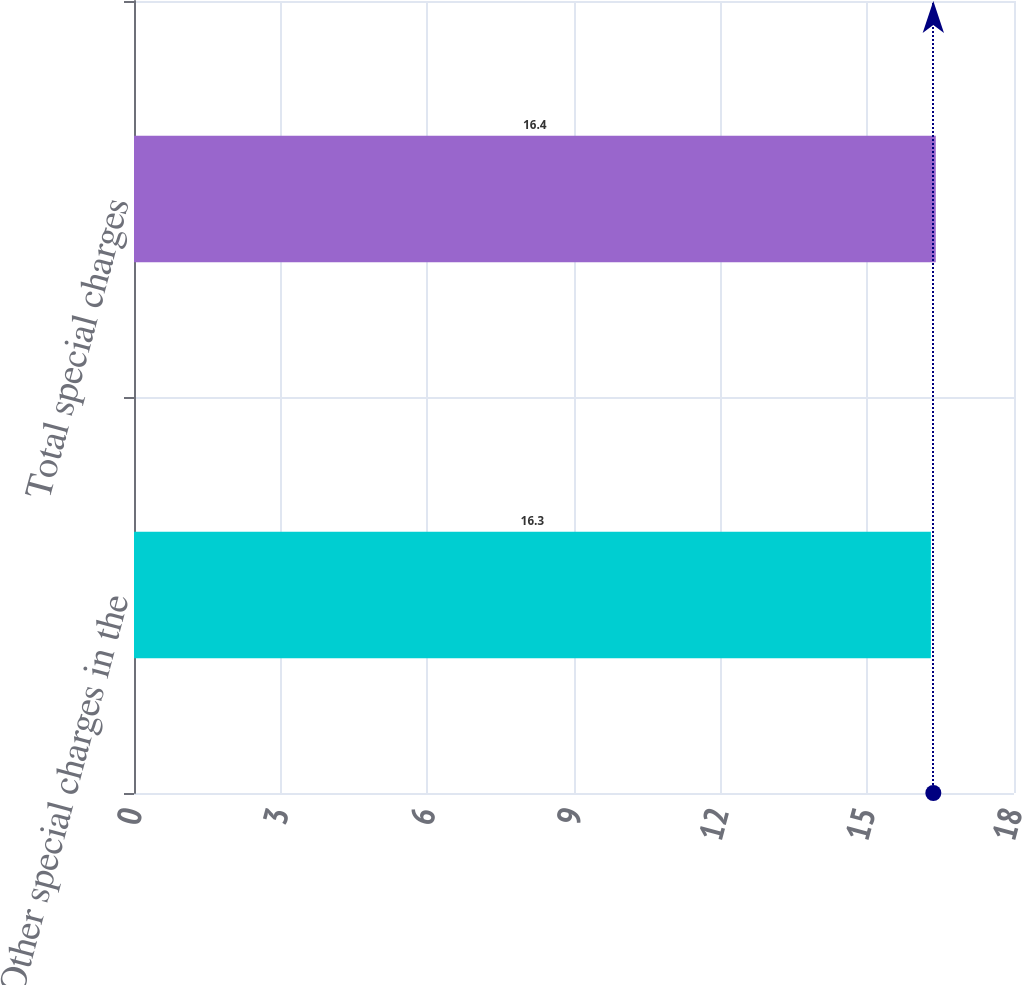Convert chart to OTSL. <chart><loc_0><loc_0><loc_500><loc_500><bar_chart><fcel>Other special charges in the<fcel>Total special charges<nl><fcel>16.3<fcel>16.4<nl></chart> 